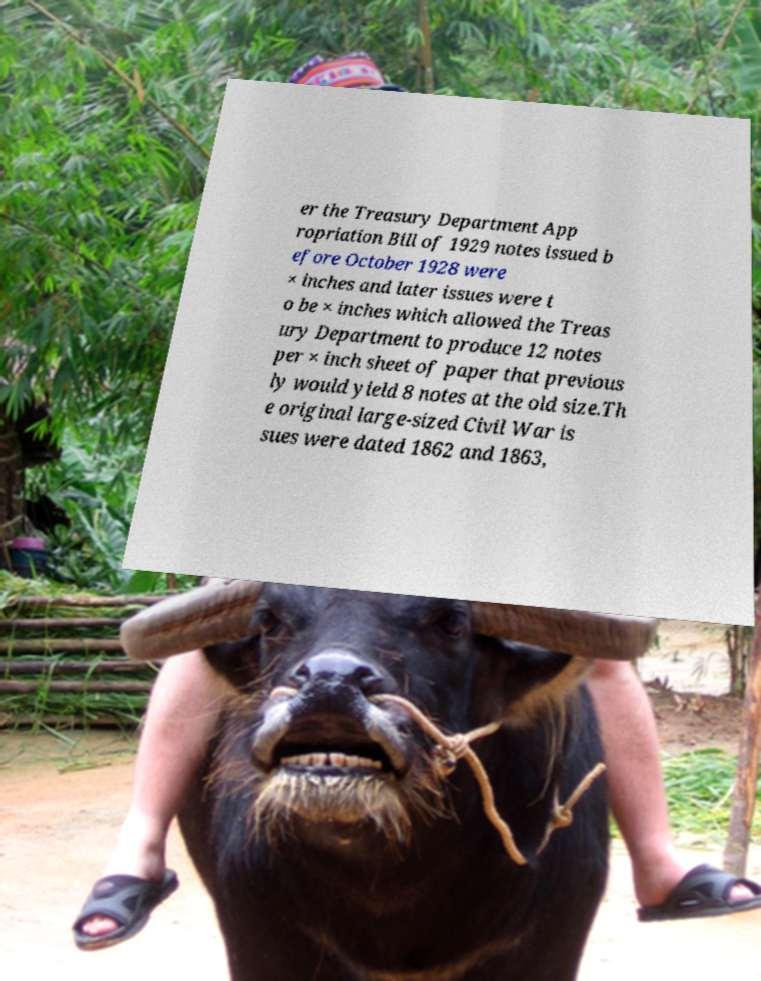Could you extract and type out the text from this image? er the Treasury Department App ropriation Bill of 1929 notes issued b efore October 1928 were × inches and later issues were t o be × inches which allowed the Treas ury Department to produce 12 notes per × inch sheet of paper that previous ly would yield 8 notes at the old size.Th e original large-sized Civil War is sues were dated 1862 and 1863, 